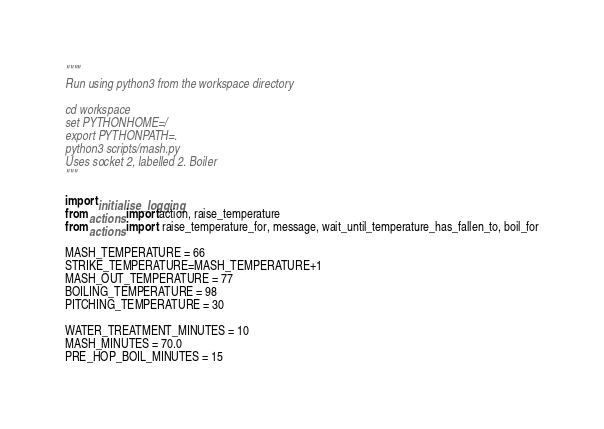Convert code to text. <code><loc_0><loc_0><loc_500><loc_500><_Python_>""""
Run using python3 from the workspace directory

cd workspace
set PYTHONHOME=/
export PYTHONPATH=.
python3 scripts/mash.py
Uses socket 2, labelled 2. Boiler
"""

import initialise_logging
from actions import action, raise_temperature
from actions import  raise_temperature_for, message, wait_until_temperature_has_fallen_to, boil_for

MASH_TEMPERATURE = 66
STRIKE_TEMPERATURE=MASH_TEMPERATURE+1
MASH_OUT_TEMPERATURE = 77
BOILING_TEMPERATURE = 98
PITCHING_TEMPERATURE = 30

WATER_TREATMENT_MINUTES = 10
MASH_MINUTES = 70.0
PRE_HOP_BOIL_MINUTES = 15</code> 